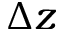<formula> <loc_0><loc_0><loc_500><loc_500>\Delta z</formula> 